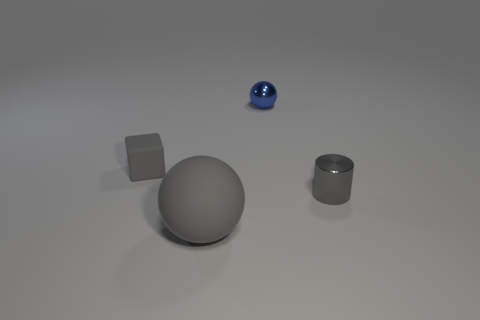What is the size of the matte object that is on the right side of the tiny gray thing on the left side of the rubber ball?
Offer a very short reply. Large. Is the number of large matte objects that are behind the tiny blue object greater than the number of large yellow spheres?
Offer a very short reply. No. There is a thing left of the gray sphere; is its size the same as the metallic sphere?
Make the answer very short. Yes. The tiny thing that is right of the tiny cube and behind the tiny cylinder is what color?
Offer a very short reply. Blue. There is a metal object that is the same size as the shiny cylinder; what shape is it?
Offer a very short reply. Sphere. Is there a matte ball that has the same color as the large rubber thing?
Offer a very short reply. No. Are there an equal number of large gray balls in front of the big gray matte sphere and tiny matte objects?
Offer a very short reply. No. Is the color of the rubber block the same as the small cylinder?
Provide a succinct answer. Yes. There is a thing that is both behind the cylinder and in front of the tiny blue metallic sphere; what is its size?
Offer a very short reply. Small. There is a thing that is made of the same material as the tiny gray cylinder; what is its color?
Your response must be concise. Blue. 